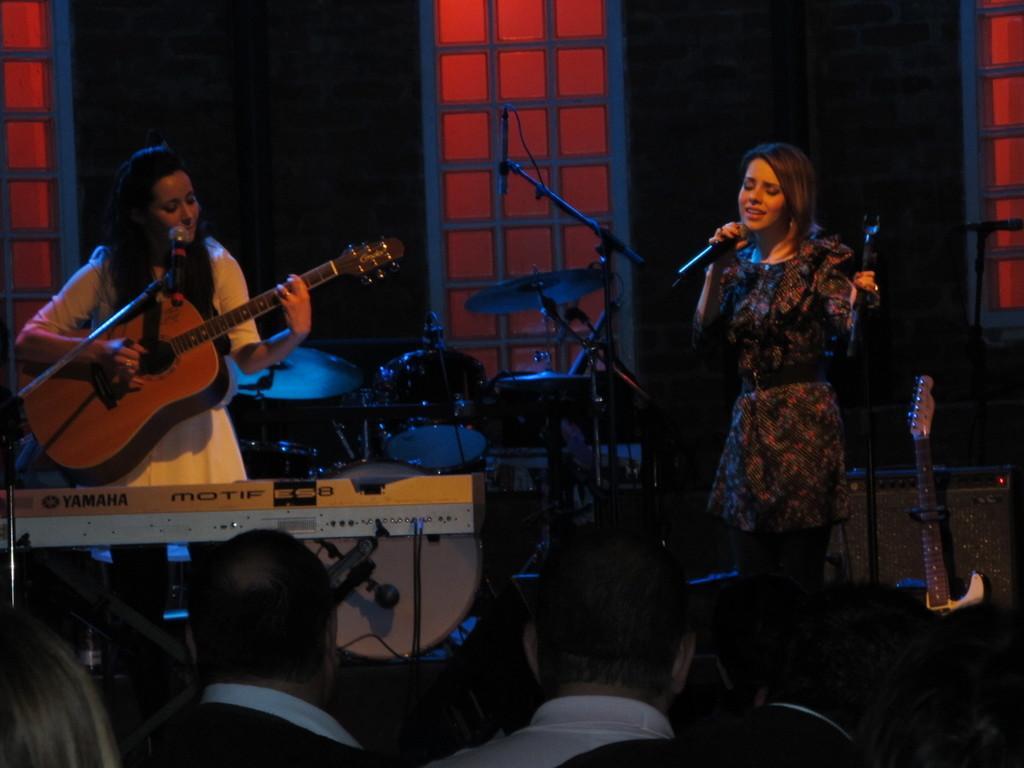Can you describe this image briefly? This picture describes about group of people, a woman is playing guitar in front of microphone, another woman is singing with the help of microphone, in front of them we can find couple of musical instruments. 